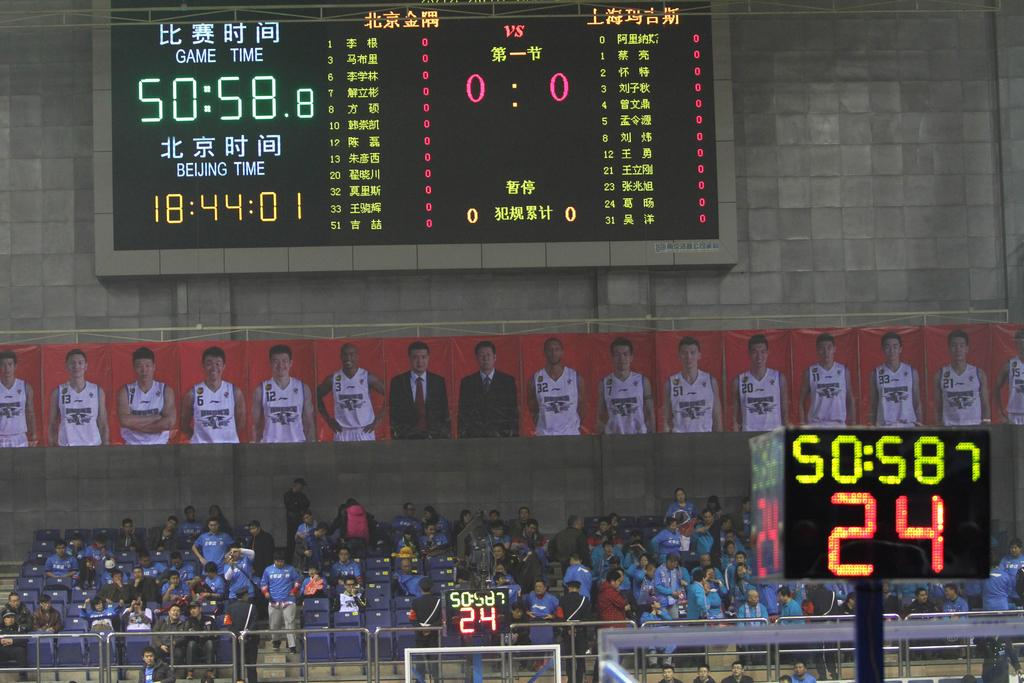<image>
Provide a brief description of the given image. A clock displays 50:58 in yellow above 24 in red. 